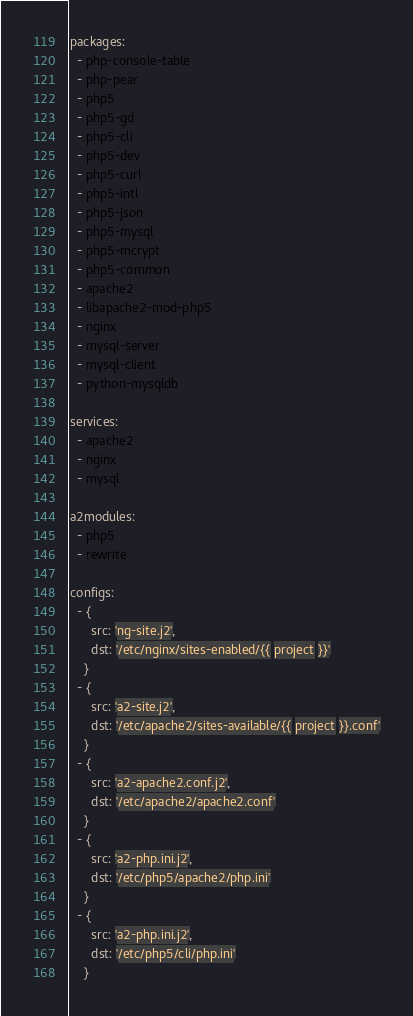Convert code to text. <code><loc_0><loc_0><loc_500><loc_500><_YAML_>packages:
  - php-console-table
  - php-pear
  - php5
  - php5-gd
  - php5-cli
  - php5-dev
  - php5-curl
  - php5-intl
  - php5-json
  - php5-mysql
  - php5-mcrypt
  - php5-common
  - apache2
  - libapache2-mod-php5
  - nginx
  - mysql-server
  - mysql-client
  - python-mysqldb

services:
  - apache2
  - nginx
  - mysql

a2modules:
  - php5
  - rewrite

configs:
  - {
      src: 'ng-site.j2',
      dst: '/etc/nginx/sites-enabled/{{ project }}'
    }
  - {
      src: 'a2-site.j2',
      dst: '/etc/apache2/sites-available/{{ project }}.conf'
    }
  - {
      src: 'a2-apache2.conf.j2',
      dst: '/etc/apache2/apache2.conf'
    }
  - {
      src: 'a2-php.ini.j2',
      dst: '/etc/php5/apache2/php.ini'
    }
  - {
      src: 'a2-php.ini.j2',
      dst: '/etc/php5/cli/php.ini'
    }
</code> 